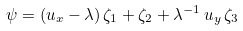<formula> <loc_0><loc_0><loc_500><loc_500>\psi = ( u _ { x } - \lambda ) \, \zeta _ { 1 } + \zeta _ { 2 } + \lambda ^ { - 1 } \, u _ { y } \, \zeta _ { 3 }</formula> 